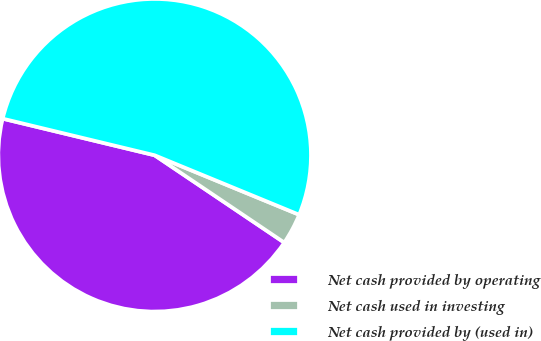Convert chart to OTSL. <chart><loc_0><loc_0><loc_500><loc_500><pie_chart><fcel>Net cash provided by operating<fcel>Net cash used in investing<fcel>Net cash provided by (used in)<nl><fcel>44.33%<fcel>3.22%<fcel>52.45%<nl></chart> 